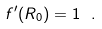Convert formula to latex. <formula><loc_0><loc_0><loc_500><loc_500>f ^ { \prime } ( R _ { 0 } ) = 1 \ .</formula> 